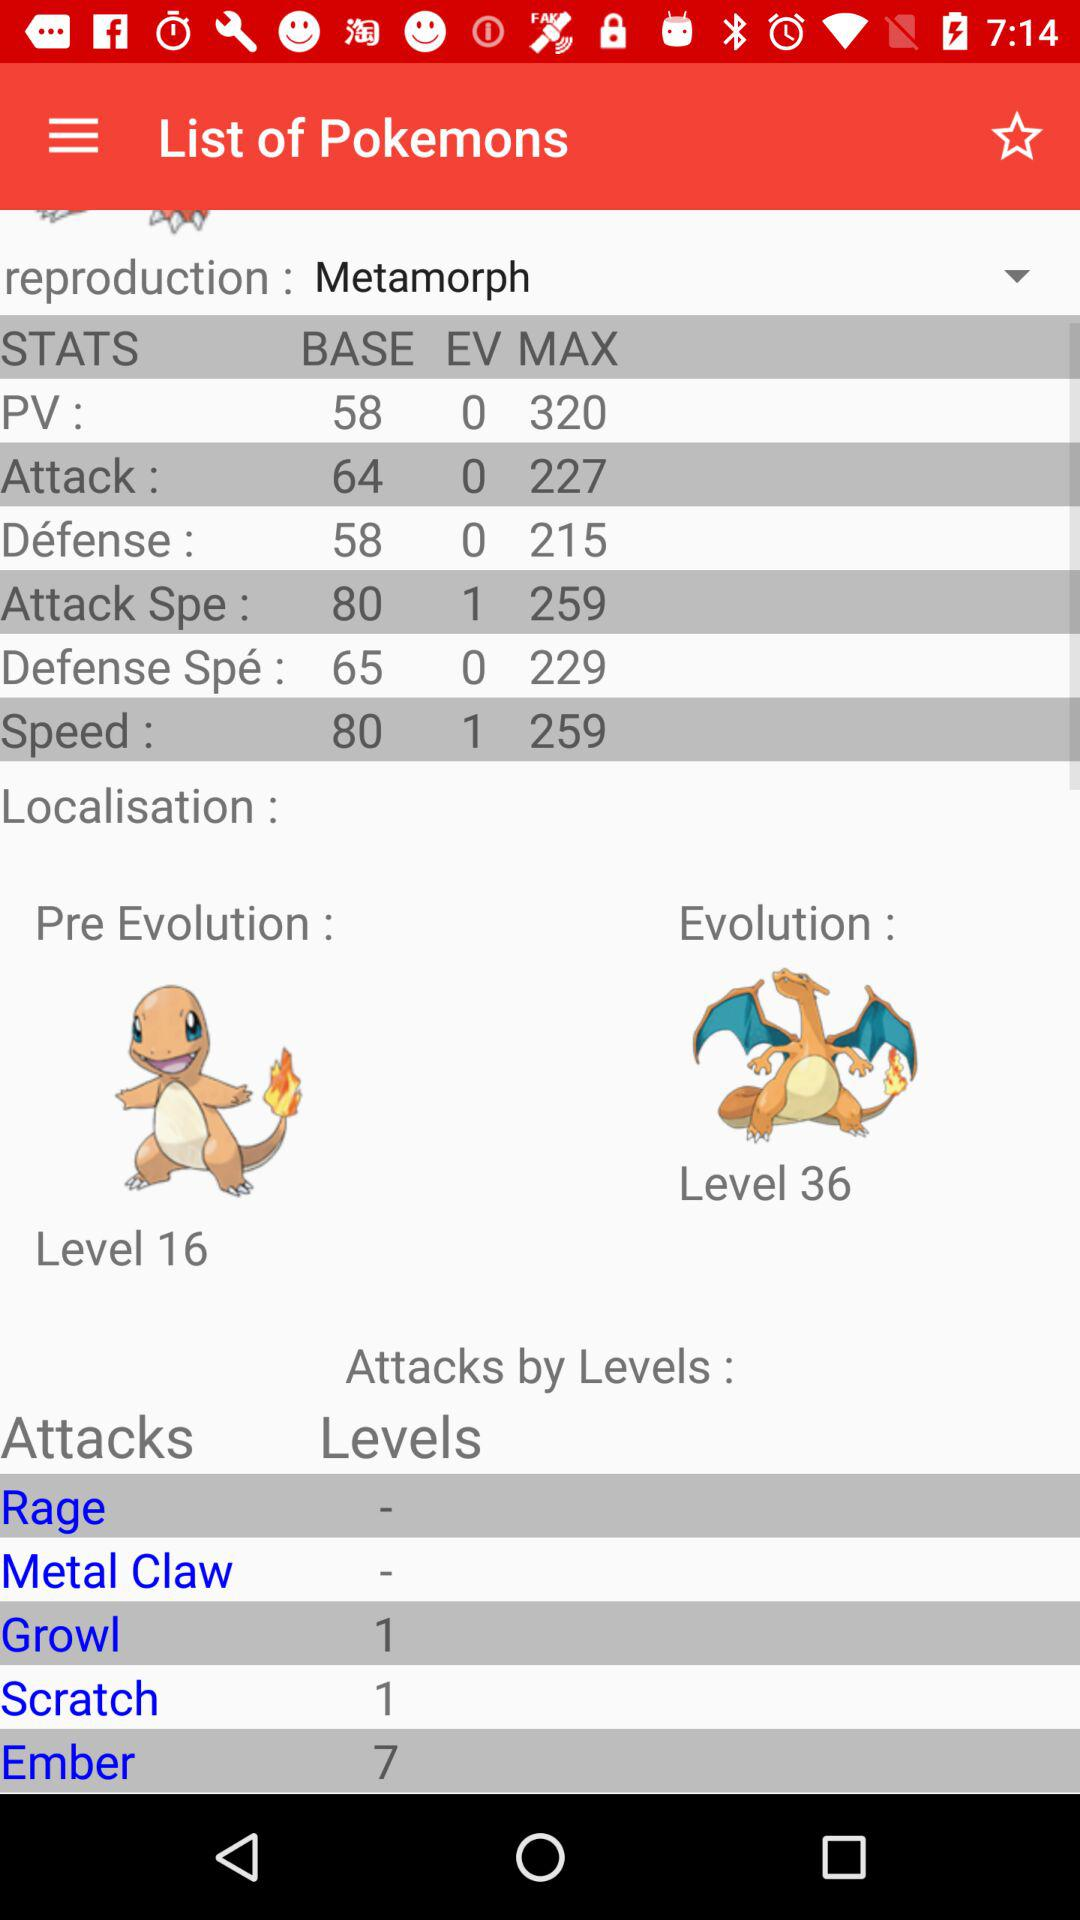What is the level of pre-evolution? The level of pre-evolution is 16. 